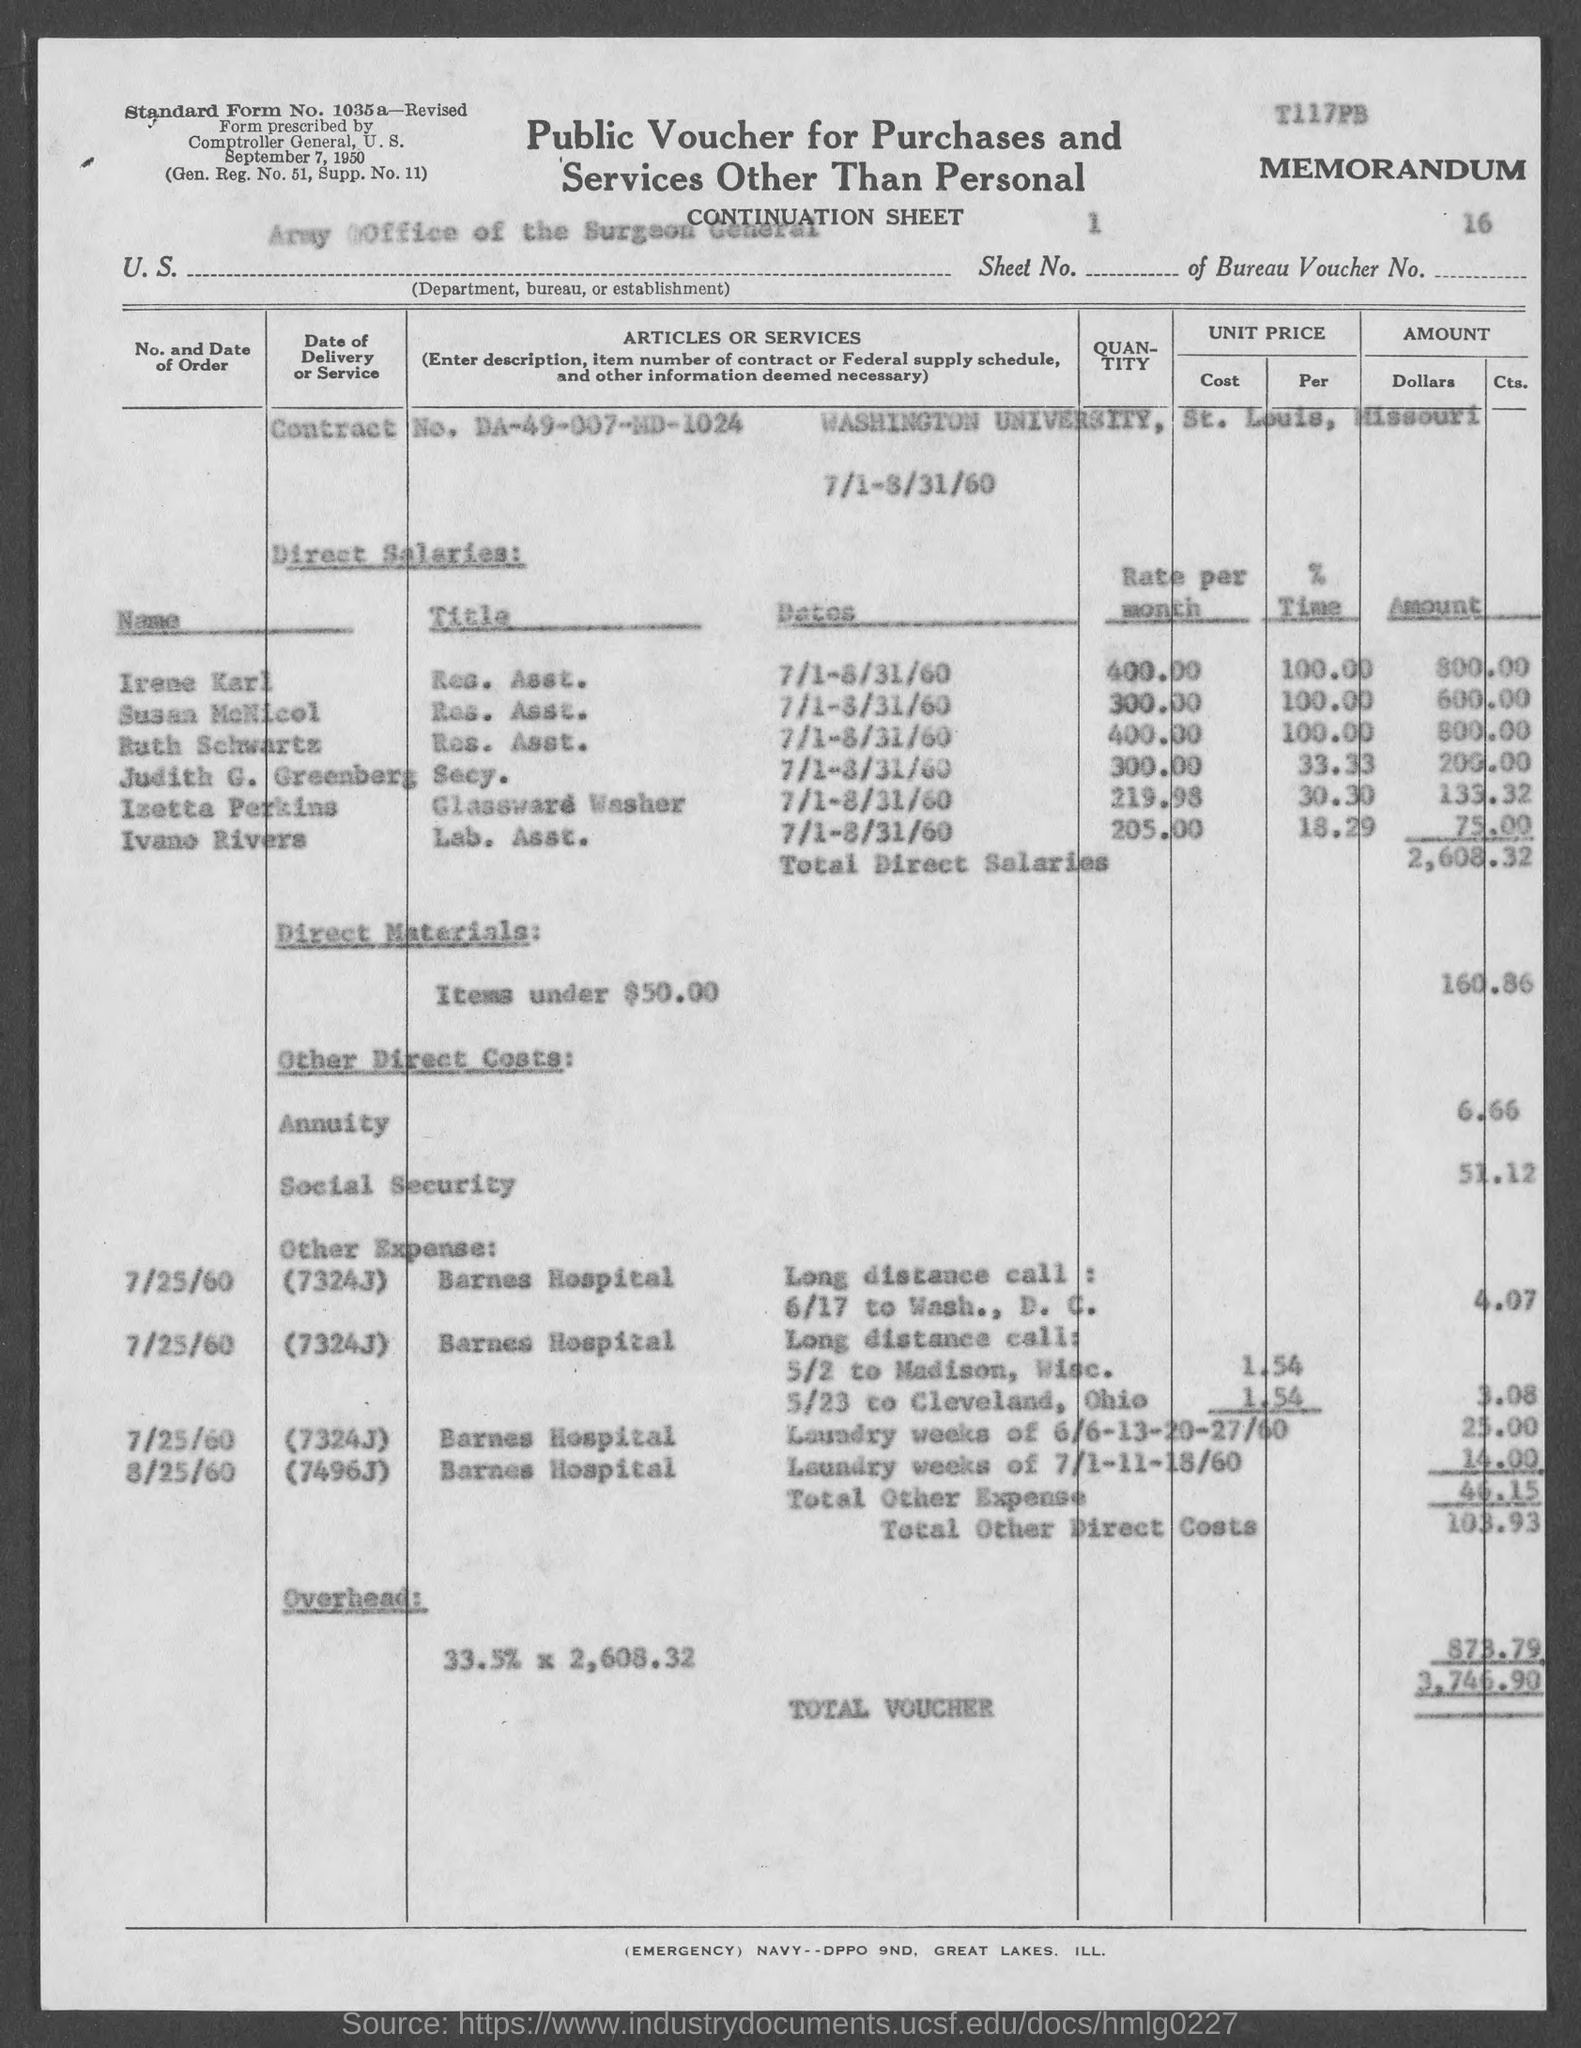Outline some significant characteristics in this image. The bureau voucher number mentioned in the given form is 16... I am not sure what you are referring to. Could you please provide more context or information about the form and the annuity amount mentioned in it? This will help me understand your question better and provide a more accurate response. The contract number mentioned in the given form is DA-49-007-MD-1024.. The total voucher amount mentioned in the given form is 3,746.90. The amount of direct materials mentioned in the given page is 160.86. 